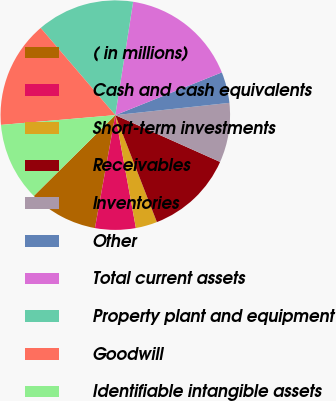Convert chart. <chart><loc_0><loc_0><loc_500><loc_500><pie_chart><fcel>( in millions)<fcel>Cash and cash equivalents<fcel>Short-term investments<fcel>Receivables<fcel>Inventories<fcel>Other<fcel>Total current assets<fcel>Property plant and equipment<fcel>Goodwill<fcel>Identifiable intangible assets<nl><fcel>9.73%<fcel>5.71%<fcel>3.03%<fcel>12.41%<fcel>8.39%<fcel>4.37%<fcel>16.44%<fcel>13.75%<fcel>15.09%<fcel>11.07%<nl></chart> 